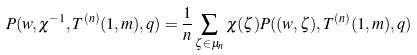<formula> <loc_0><loc_0><loc_500><loc_500>P ( w , \chi ^ { - 1 } , T ^ { ( n ) } ( 1 , m ) , q ) = \frac { 1 } { n } \sum _ { \zeta \in \mu _ { n } } \chi ( \zeta ) P ( ( w , \zeta ) , T ^ { ( n ) } ( 1 , m ) , q )</formula> 